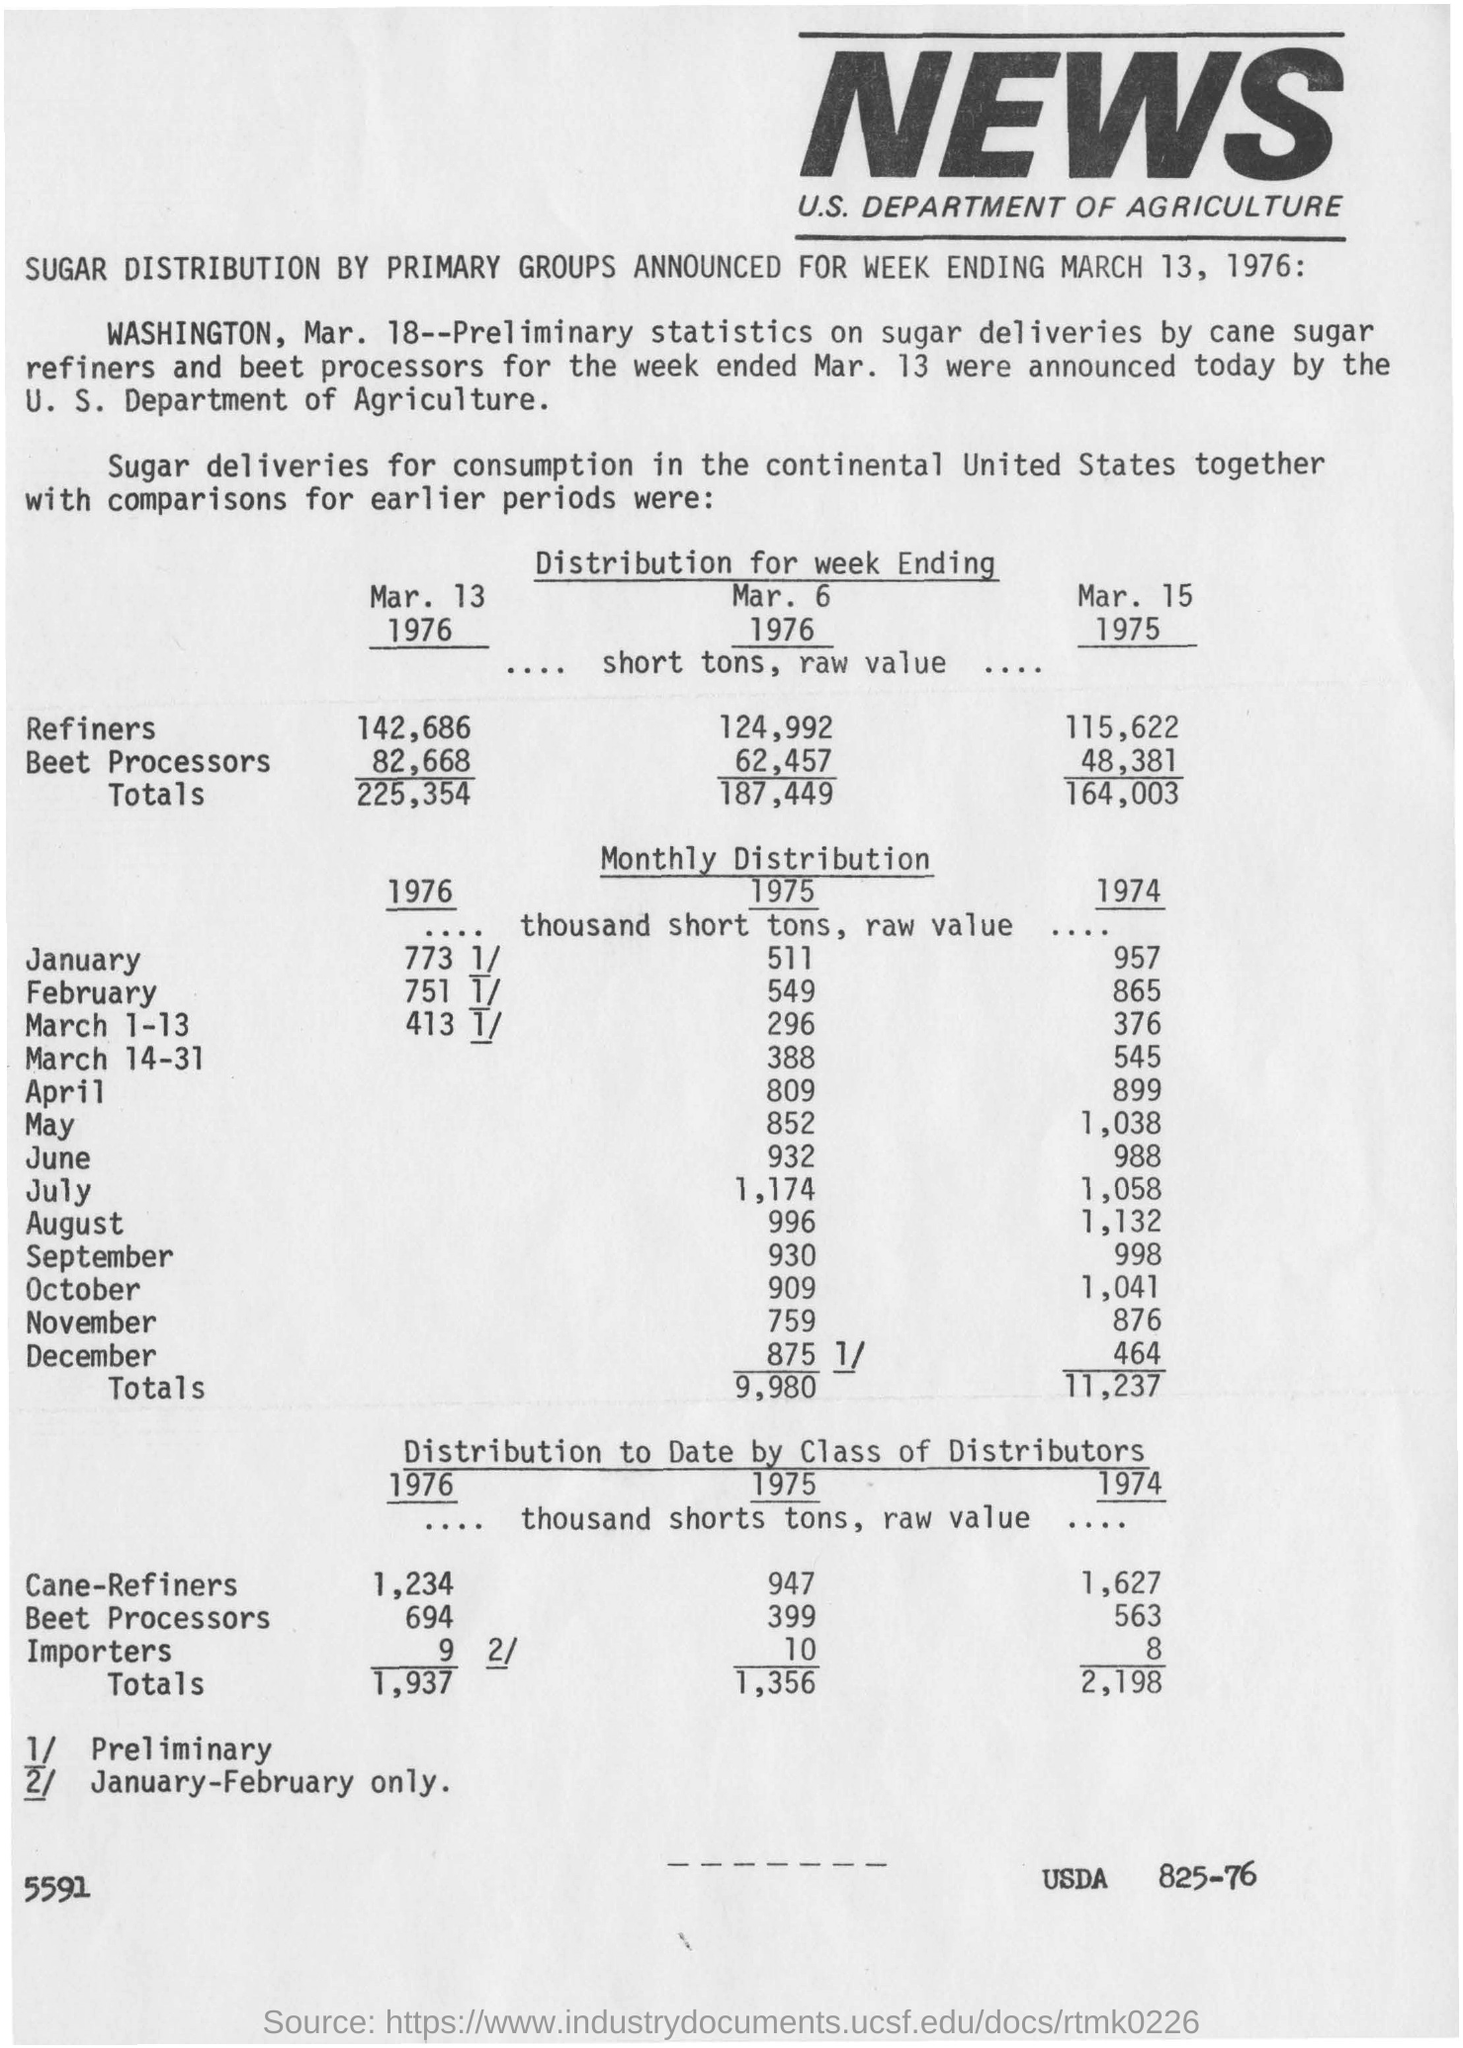Specify some key components in this picture. The article discusses the distribution of sugar. In 1975, the value of importers was 10... News coverage is prevalent in the United States. 